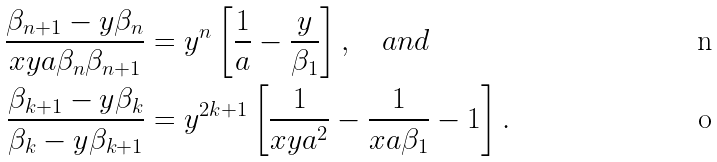<formula> <loc_0><loc_0><loc_500><loc_500>\frac { \beta _ { n + 1 } - y \beta _ { n } } { x y a \beta _ { n } \beta _ { n + 1 } } & = y ^ { n } \left [ \frac { 1 } { a } - \frac { y } { \beta _ { 1 } } \right ] , \quad a n d \\ \frac { \beta _ { k + 1 } - y \beta _ { k } } { \beta _ { k } - y \beta _ { k + 1 } } & = y ^ { 2 k + 1 } \left [ \frac { 1 } { x y a ^ { 2 } } - \frac { 1 } { x a \beta _ { 1 } } - 1 \right ] .</formula> 